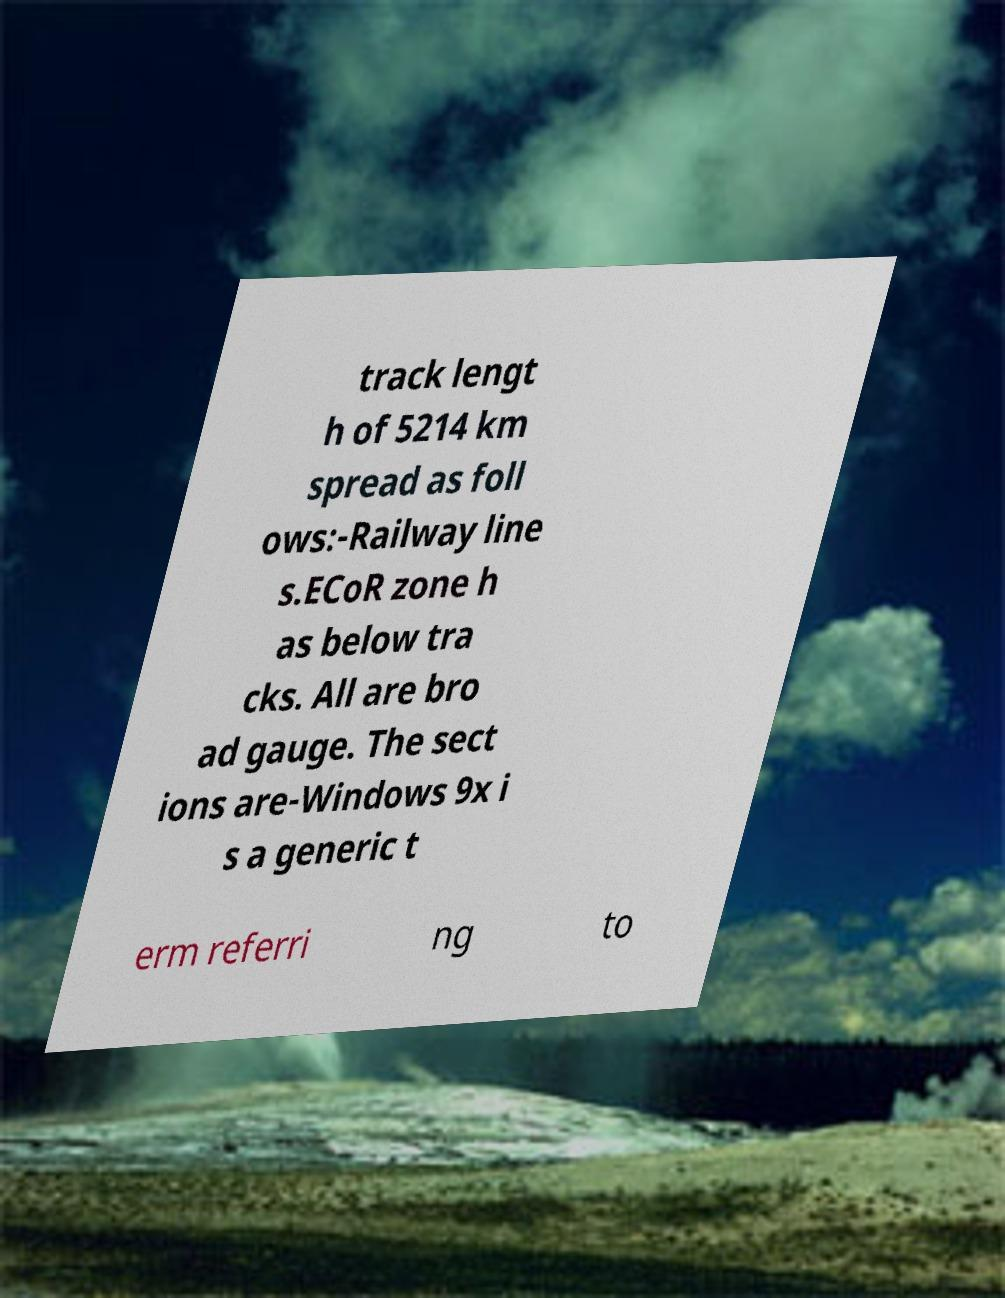I need the written content from this picture converted into text. Can you do that? track lengt h of 5214 km spread as foll ows:-Railway line s.ECoR zone h as below tra cks. All are bro ad gauge. The sect ions are-Windows 9x i s a generic t erm referri ng to 